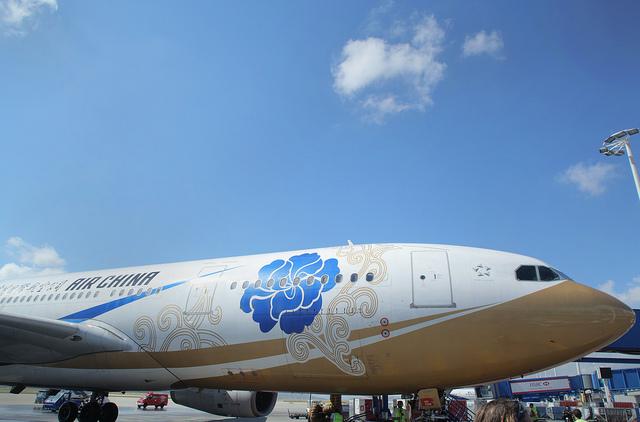Is that a blue flower on the plane?
Give a very brief answer. Yes. What airline is the airplane from?
Short answer required. Air china. What airline owns this plane?
Keep it brief. Air china. 